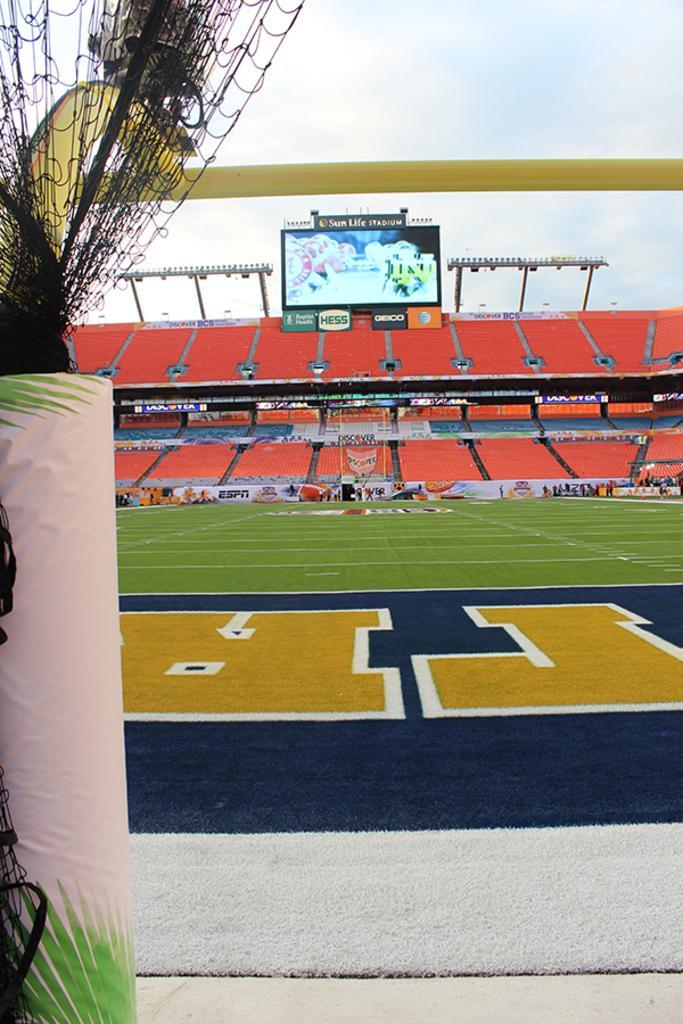Can you describe this image briefly? In this image I can see football ground and in background I can see a screen. I can also see white lines on ground and over there I can see something is written. I can also see the sky in background. 